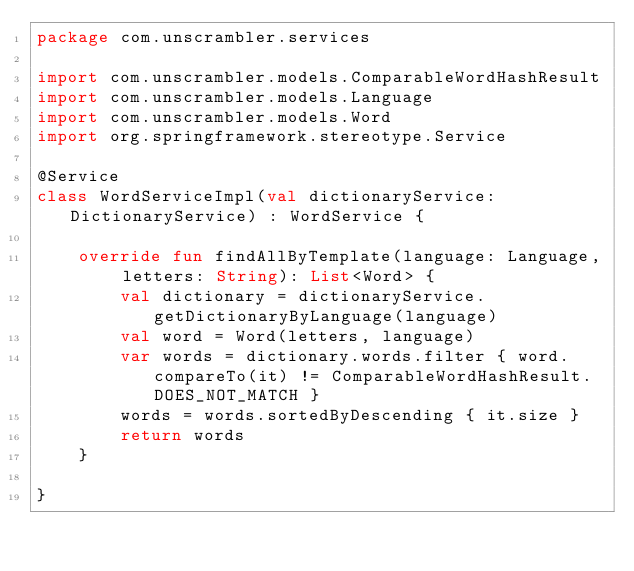<code> <loc_0><loc_0><loc_500><loc_500><_Kotlin_>package com.unscrambler.services

import com.unscrambler.models.ComparableWordHashResult
import com.unscrambler.models.Language
import com.unscrambler.models.Word
import org.springframework.stereotype.Service

@Service
class WordServiceImpl(val dictionaryService: DictionaryService) : WordService {

    override fun findAllByTemplate(language: Language, letters: String): List<Word> {
        val dictionary = dictionaryService.getDictionaryByLanguage(language)
        val word = Word(letters, language)
        var words = dictionary.words.filter { word.compareTo(it) != ComparableWordHashResult.DOES_NOT_MATCH }
        words = words.sortedByDescending { it.size }
        return words
    }

}
</code> 